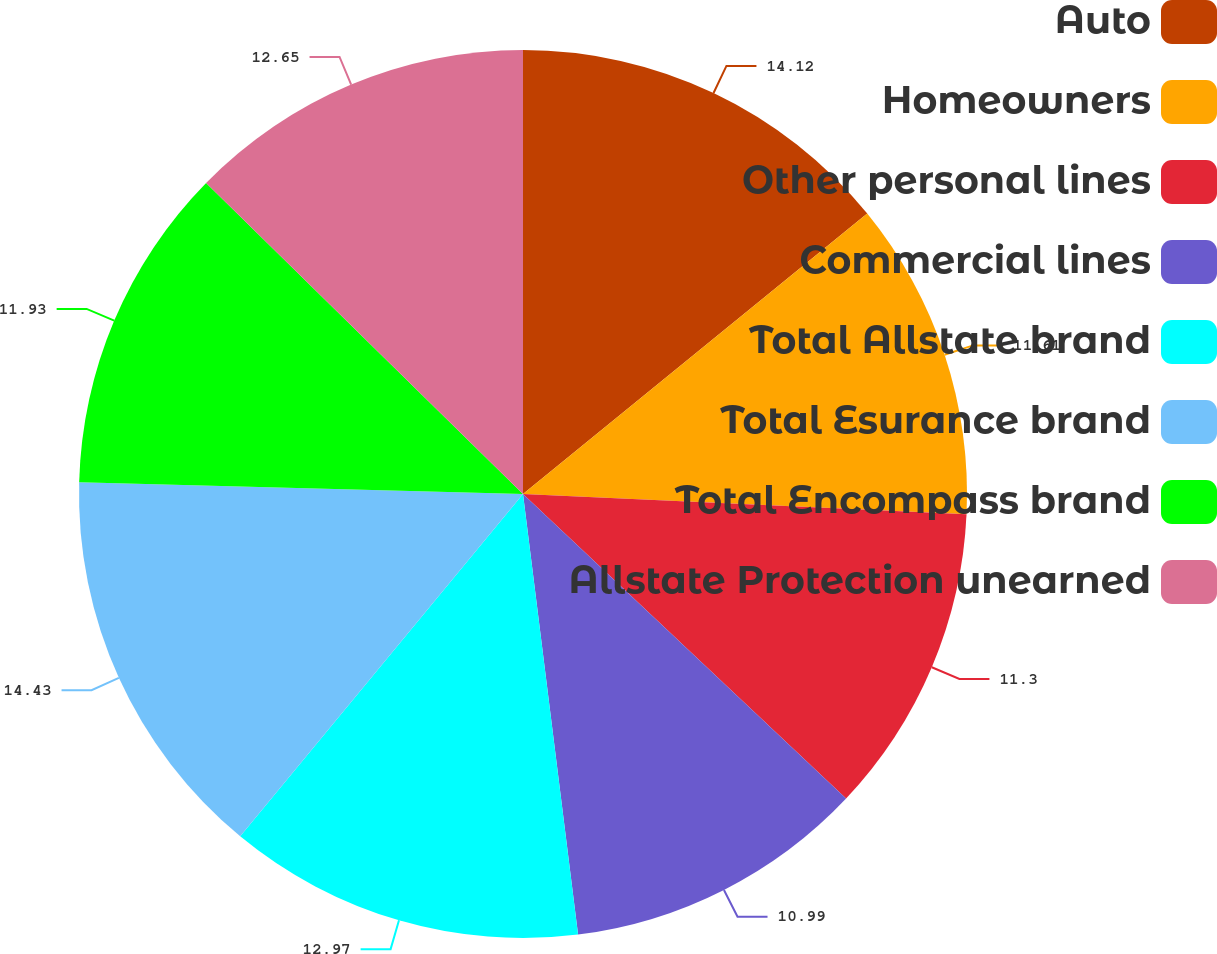Convert chart. <chart><loc_0><loc_0><loc_500><loc_500><pie_chart><fcel>Auto<fcel>Homeowners<fcel>Other personal lines<fcel>Commercial lines<fcel>Total Allstate brand<fcel>Total Esurance brand<fcel>Total Encompass brand<fcel>Allstate Protection unearned<nl><fcel>14.12%<fcel>11.61%<fcel>11.3%<fcel>10.99%<fcel>12.97%<fcel>14.43%<fcel>11.93%<fcel>12.65%<nl></chart> 